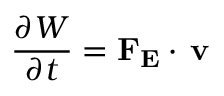<formula> <loc_0><loc_0><loc_500><loc_500>{ \frac { \partial W } { \partial t } } = F _ { E } \cdot \, v</formula> 